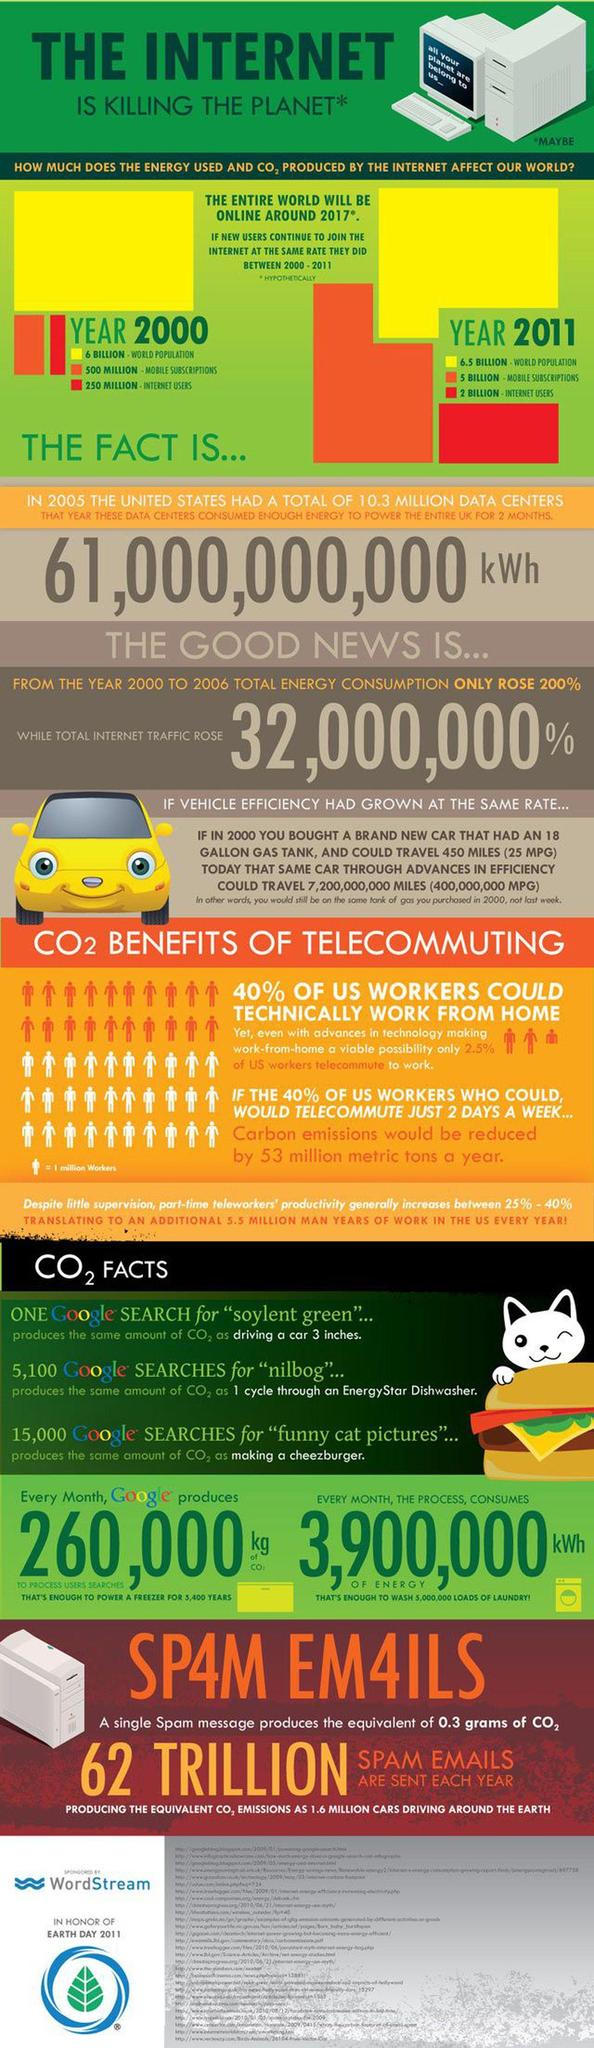Mention a couple of crucial points in this snapshot. In 2011, the world population was approximately 0.5 billion more than it was in 2000. According to a recent survey, 60% of US workers are not working from home. The total number of mobile subscription and internet users is approximately 750 million. 